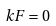Convert formula to latex. <formula><loc_0><loc_0><loc_500><loc_500>k F = 0</formula> 